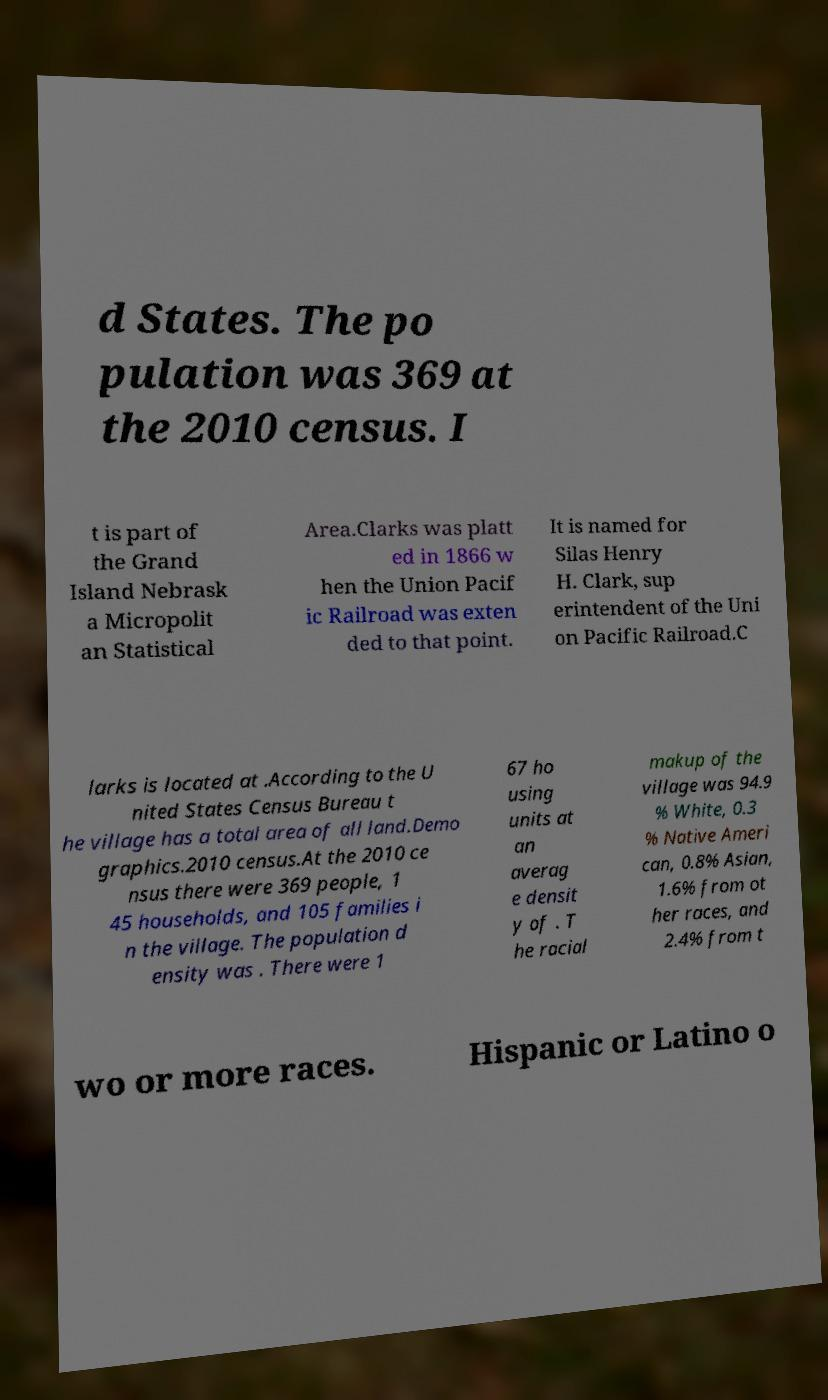Can you read and provide the text displayed in the image?This photo seems to have some interesting text. Can you extract and type it out for me? d States. The po pulation was 369 at the 2010 census. I t is part of the Grand Island Nebrask a Micropolit an Statistical Area.Clarks was platt ed in 1866 w hen the Union Pacif ic Railroad was exten ded to that point. It is named for Silas Henry H. Clark, sup erintendent of the Uni on Pacific Railroad.C larks is located at .According to the U nited States Census Bureau t he village has a total area of all land.Demo graphics.2010 census.At the 2010 ce nsus there were 369 people, 1 45 households, and 105 families i n the village. The population d ensity was . There were 1 67 ho using units at an averag e densit y of . T he racial makup of the village was 94.9 % White, 0.3 % Native Ameri can, 0.8% Asian, 1.6% from ot her races, and 2.4% from t wo or more races. Hispanic or Latino o 